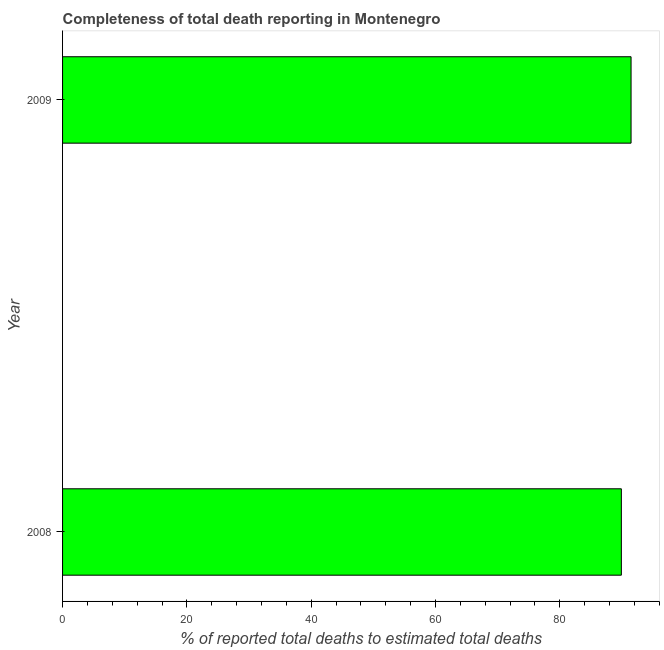What is the title of the graph?
Offer a very short reply. Completeness of total death reporting in Montenegro. What is the label or title of the X-axis?
Your response must be concise. % of reported total deaths to estimated total deaths. What is the completeness of total death reports in 2008?
Your answer should be compact. 89.92. Across all years, what is the maximum completeness of total death reports?
Provide a succinct answer. 91.48. Across all years, what is the minimum completeness of total death reports?
Ensure brevity in your answer.  89.92. What is the sum of the completeness of total death reports?
Your answer should be very brief. 181.4. What is the difference between the completeness of total death reports in 2008 and 2009?
Your response must be concise. -1.56. What is the average completeness of total death reports per year?
Provide a succinct answer. 90.7. What is the median completeness of total death reports?
Your answer should be very brief. 90.7. Do a majority of the years between 2008 and 2009 (inclusive) have completeness of total death reports greater than 48 %?
Offer a terse response. Yes. Is the completeness of total death reports in 2008 less than that in 2009?
Provide a succinct answer. Yes. How many bars are there?
Provide a succinct answer. 2. What is the difference between two consecutive major ticks on the X-axis?
Provide a succinct answer. 20. What is the % of reported total deaths to estimated total deaths of 2008?
Your answer should be compact. 89.92. What is the % of reported total deaths to estimated total deaths in 2009?
Offer a terse response. 91.48. What is the difference between the % of reported total deaths to estimated total deaths in 2008 and 2009?
Your answer should be very brief. -1.56. What is the ratio of the % of reported total deaths to estimated total deaths in 2008 to that in 2009?
Your response must be concise. 0.98. 